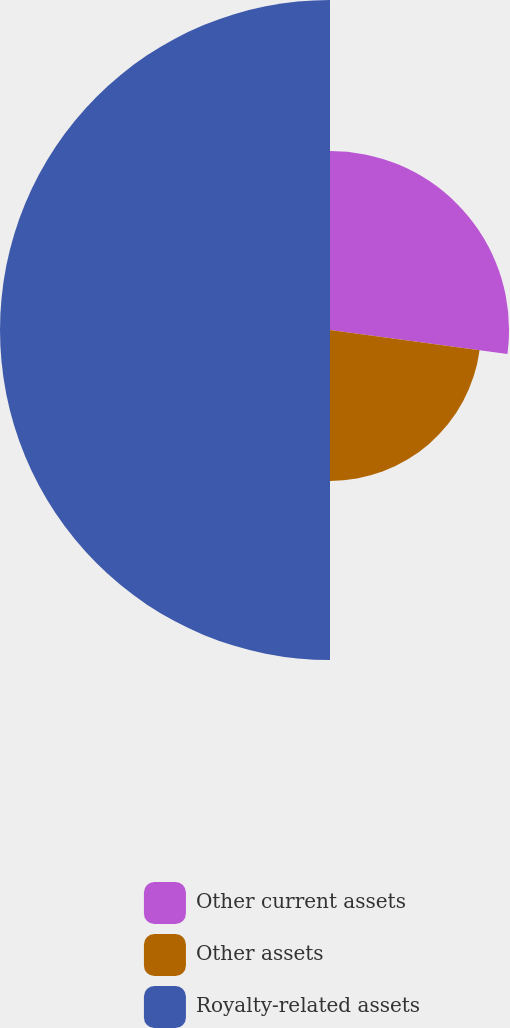Convert chart to OTSL. <chart><loc_0><loc_0><loc_500><loc_500><pie_chart><fcel>Other current assets<fcel>Other assets<fcel>Royalty-related assets<nl><fcel>27.13%<fcel>22.87%<fcel>50.0%<nl></chart> 